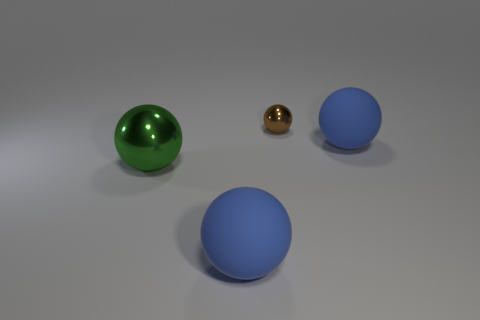Can you tell me the colors of the spheres from left to right? Certainly! From left to right, the spheres are colored green, gold, and blue respectively. 